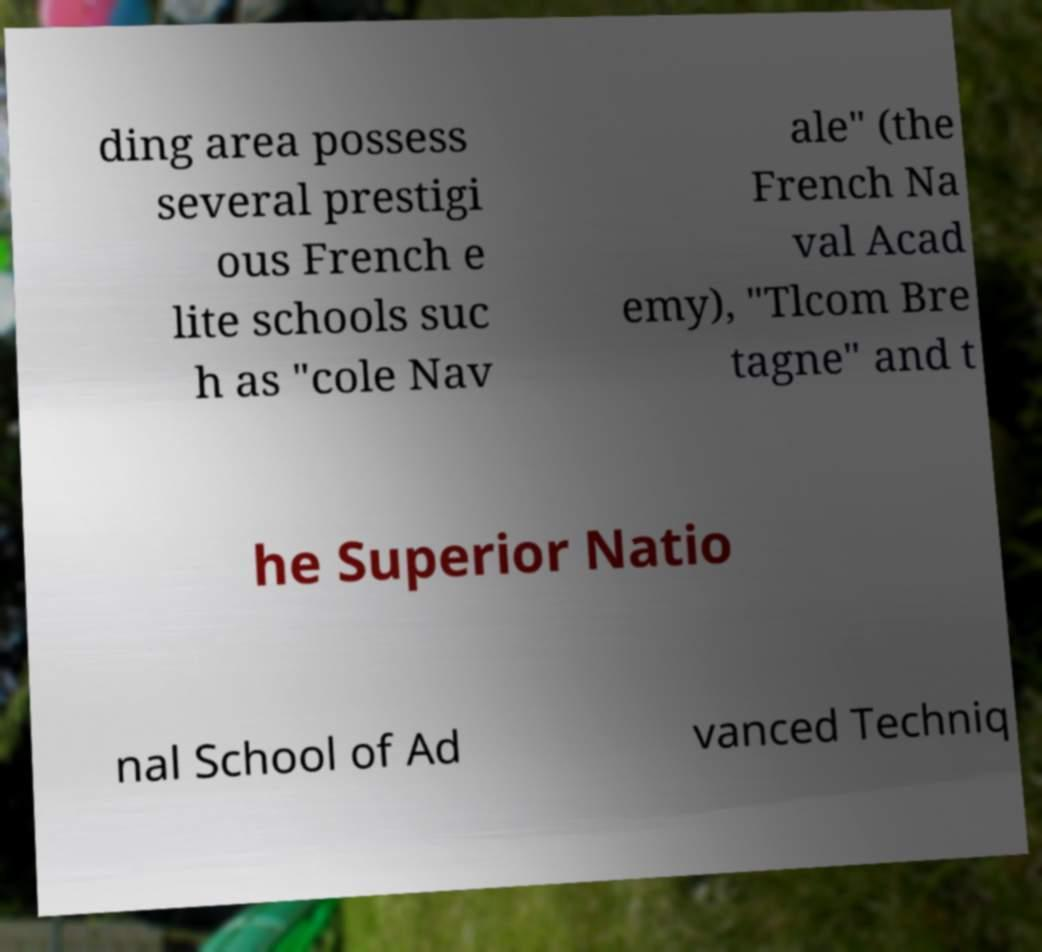Please identify and transcribe the text found in this image. ding area possess several prestigi ous French e lite schools suc h as "cole Nav ale" (the French Na val Acad emy), "Tlcom Bre tagne" and t he Superior Natio nal School of Ad vanced Techniq 